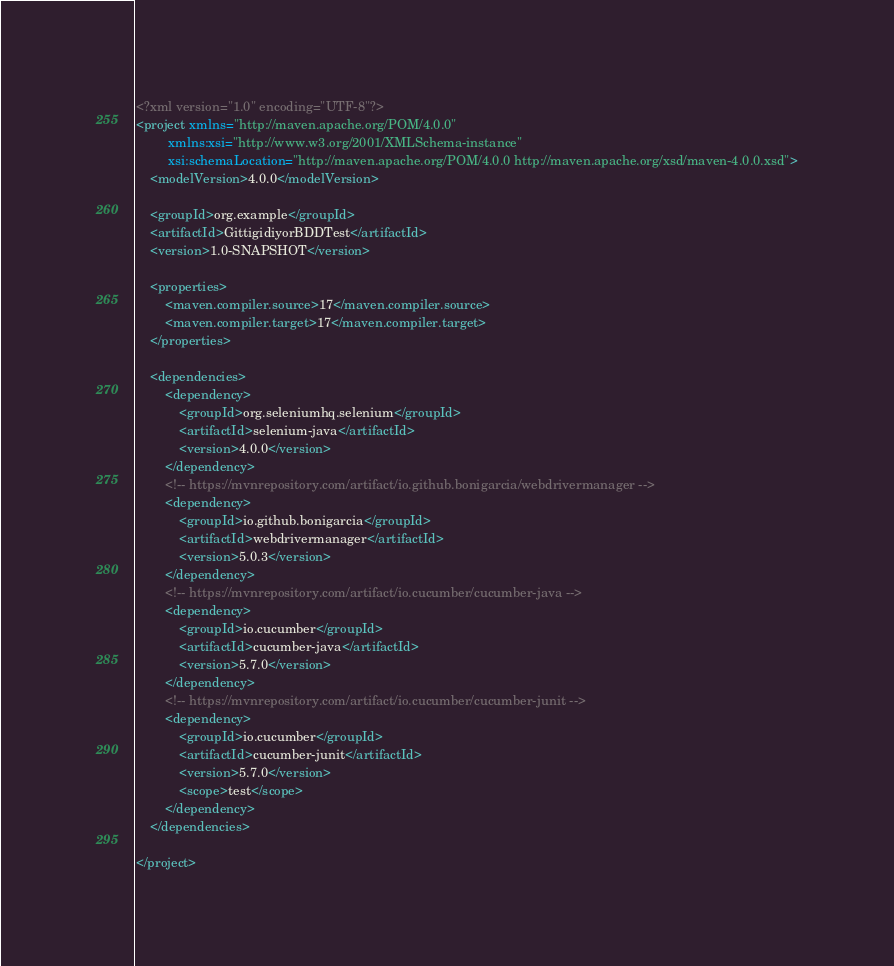<code> <loc_0><loc_0><loc_500><loc_500><_XML_><?xml version="1.0" encoding="UTF-8"?>
<project xmlns="http://maven.apache.org/POM/4.0.0"
         xmlns:xsi="http://www.w3.org/2001/XMLSchema-instance"
         xsi:schemaLocation="http://maven.apache.org/POM/4.0.0 http://maven.apache.org/xsd/maven-4.0.0.xsd">
    <modelVersion>4.0.0</modelVersion>

    <groupId>org.example</groupId>
    <artifactId>GittigidiyorBDDTest</artifactId>
    <version>1.0-SNAPSHOT</version>

    <properties>
        <maven.compiler.source>17</maven.compiler.source>
        <maven.compiler.target>17</maven.compiler.target>
    </properties>

    <dependencies>
        <dependency>
            <groupId>org.seleniumhq.selenium</groupId>
            <artifactId>selenium-java</artifactId>
            <version>4.0.0</version>
        </dependency>
        <!-- https://mvnrepository.com/artifact/io.github.bonigarcia/webdrivermanager -->
        <dependency>
            <groupId>io.github.bonigarcia</groupId>
            <artifactId>webdrivermanager</artifactId>
            <version>5.0.3</version>
        </dependency>
        <!-- https://mvnrepository.com/artifact/io.cucumber/cucumber-java -->
        <dependency>
            <groupId>io.cucumber</groupId>
            <artifactId>cucumber-java</artifactId>
            <version>5.7.0</version>
        </dependency>
        <!-- https://mvnrepository.com/artifact/io.cucumber/cucumber-junit -->
        <dependency>
            <groupId>io.cucumber</groupId>
            <artifactId>cucumber-junit</artifactId>
            <version>5.7.0</version>
            <scope>test</scope>
        </dependency>
    </dependencies>

</project></code> 